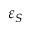Convert formula to latex. <formula><loc_0><loc_0><loc_500><loc_500>\varepsilon _ { S }</formula> 